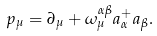<formula> <loc_0><loc_0><loc_500><loc_500>p _ { \mu } = \partial _ { \mu } + \omega _ { \mu } ^ { \alpha \beta } a _ { \alpha } ^ { + } a _ { \beta } .</formula> 